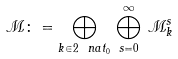<formula> <loc_0><loc_0><loc_500><loc_500>\mathcal { M } \colon = \bigoplus _ { k \in 2 \ n a t _ { 0 } } \, \bigoplus _ { s = 0 } ^ { \infty } \, \mathcal { M } _ { k } ^ { s }</formula> 